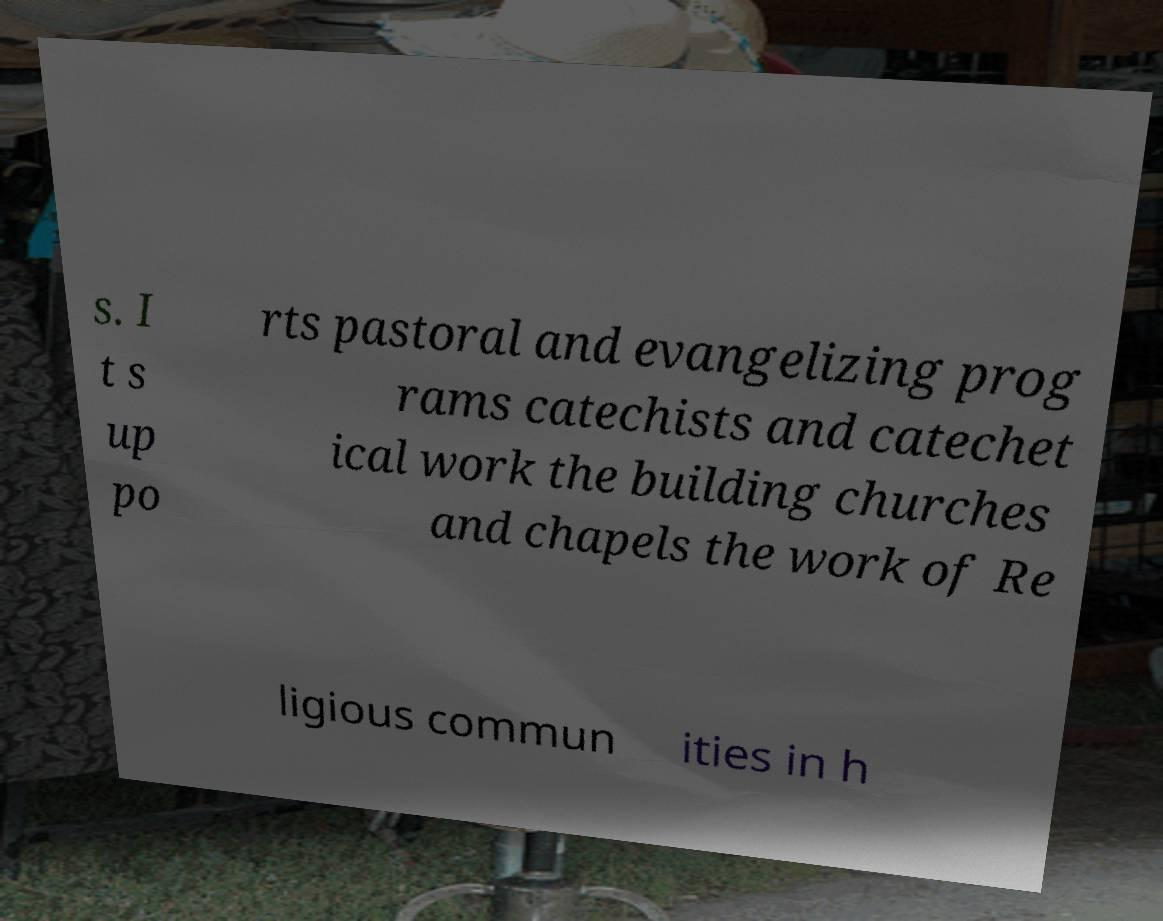Could you assist in decoding the text presented in this image and type it out clearly? s. I t s up po rts pastoral and evangelizing prog rams catechists and catechet ical work the building churches and chapels the work of Re ligious commun ities in h 